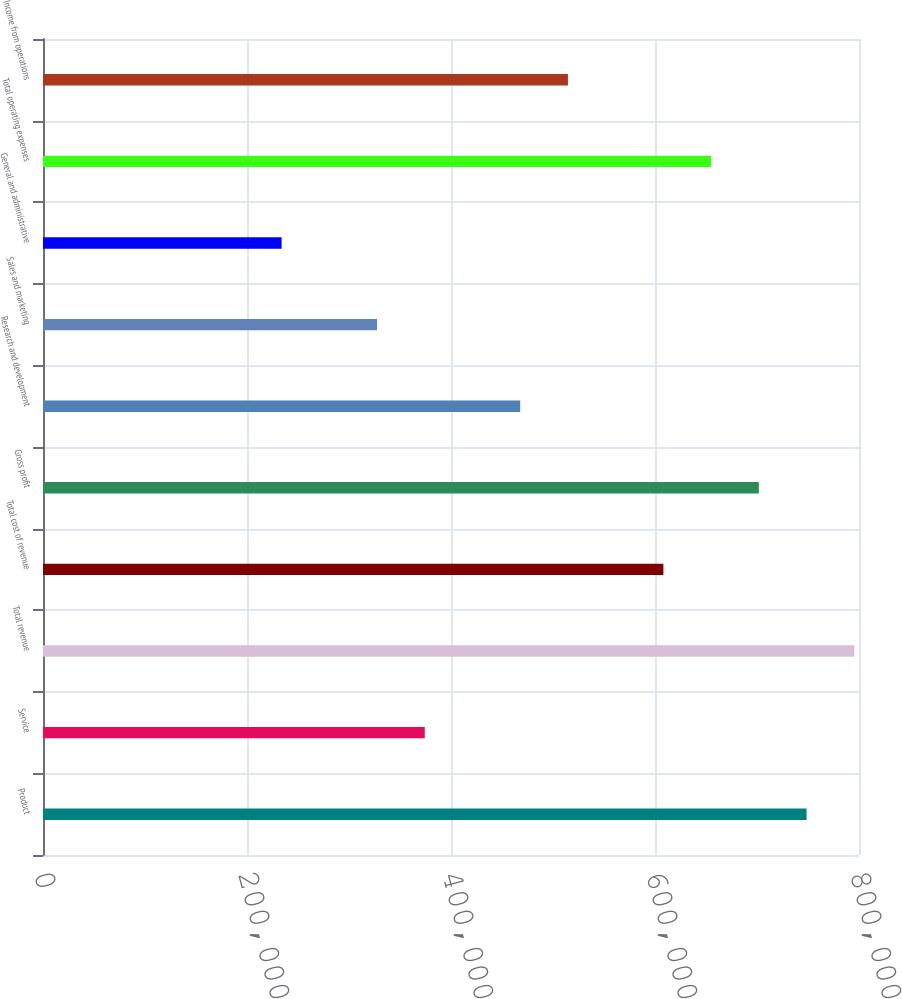Convert chart to OTSL. <chart><loc_0><loc_0><loc_500><loc_500><bar_chart><fcel>Product<fcel>Service<fcel>Total revenue<fcel>Total cost of revenue<fcel>Gross profit<fcel>Research and development<fcel>Sales and marketing<fcel>General and administrative<fcel>Total operating expenses<fcel>Income from operations<nl><fcel>748586<fcel>374294<fcel>795373<fcel>608227<fcel>701800<fcel>467867<fcel>327507<fcel>233934<fcel>655013<fcel>514654<nl></chart> 